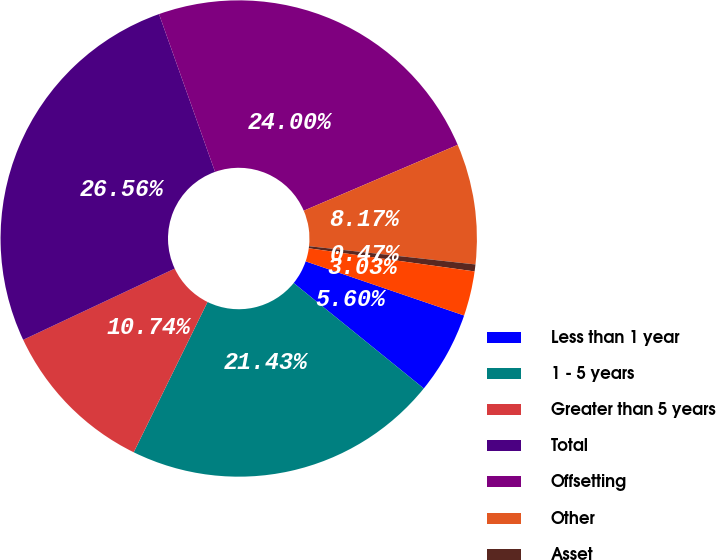Convert chart to OTSL. <chart><loc_0><loc_0><loc_500><loc_500><pie_chart><fcel>Less than 1 year<fcel>1 - 5 years<fcel>Greater than 5 years<fcel>Total<fcel>Offsetting<fcel>Other<fcel>Asset<fcel>Liability<nl><fcel>5.6%<fcel>21.43%<fcel>10.74%<fcel>26.56%<fcel>24.0%<fcel>8.17%<fcel>0.47%<fcel>3.03%<nl></chart> 